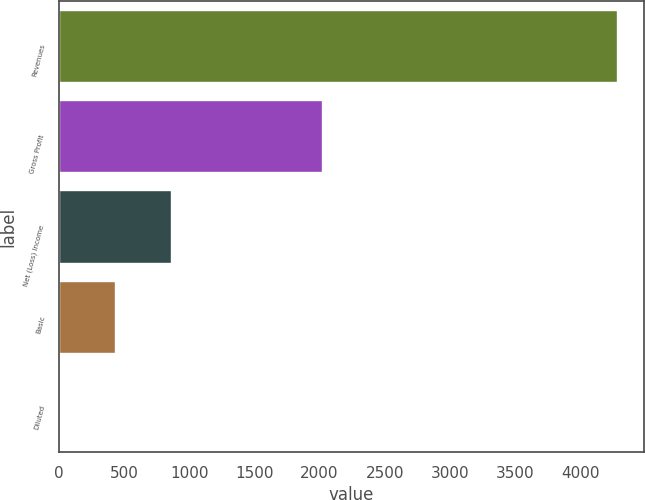<chart> <loc_0><loc_0><loc_500><loc_500><bar_chart><fcel>Revenues<fcel>Gross Profit<fcel>Net (Loss) Income<fcel>Basic<fcel>Diluted<nl><fcel>4278<fcel>2017<fcel>857.23<fcel>429.63<fcel>2.03<nl></chart> 